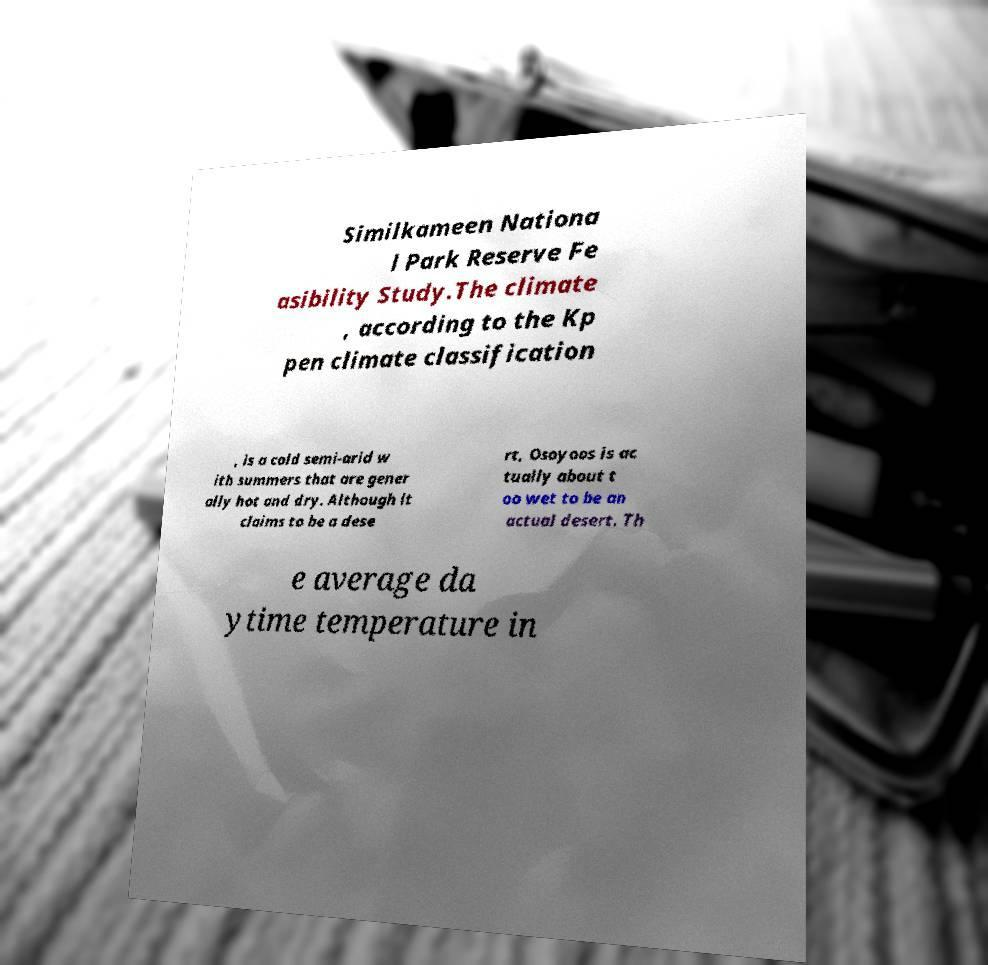Can you accurately transcribe the text from the provided image for me? Similkameen Nationa l Park Reserve Fe asibility Study.The climate , according to the Kp pen climate classification , is a cold semi-arid w ith summers that are gener ally hot and dry. Although it claims to be a dese rt, Osoyoos is ac tually about t oo wet to be an actual desert. Th e average da ytime temperature in 